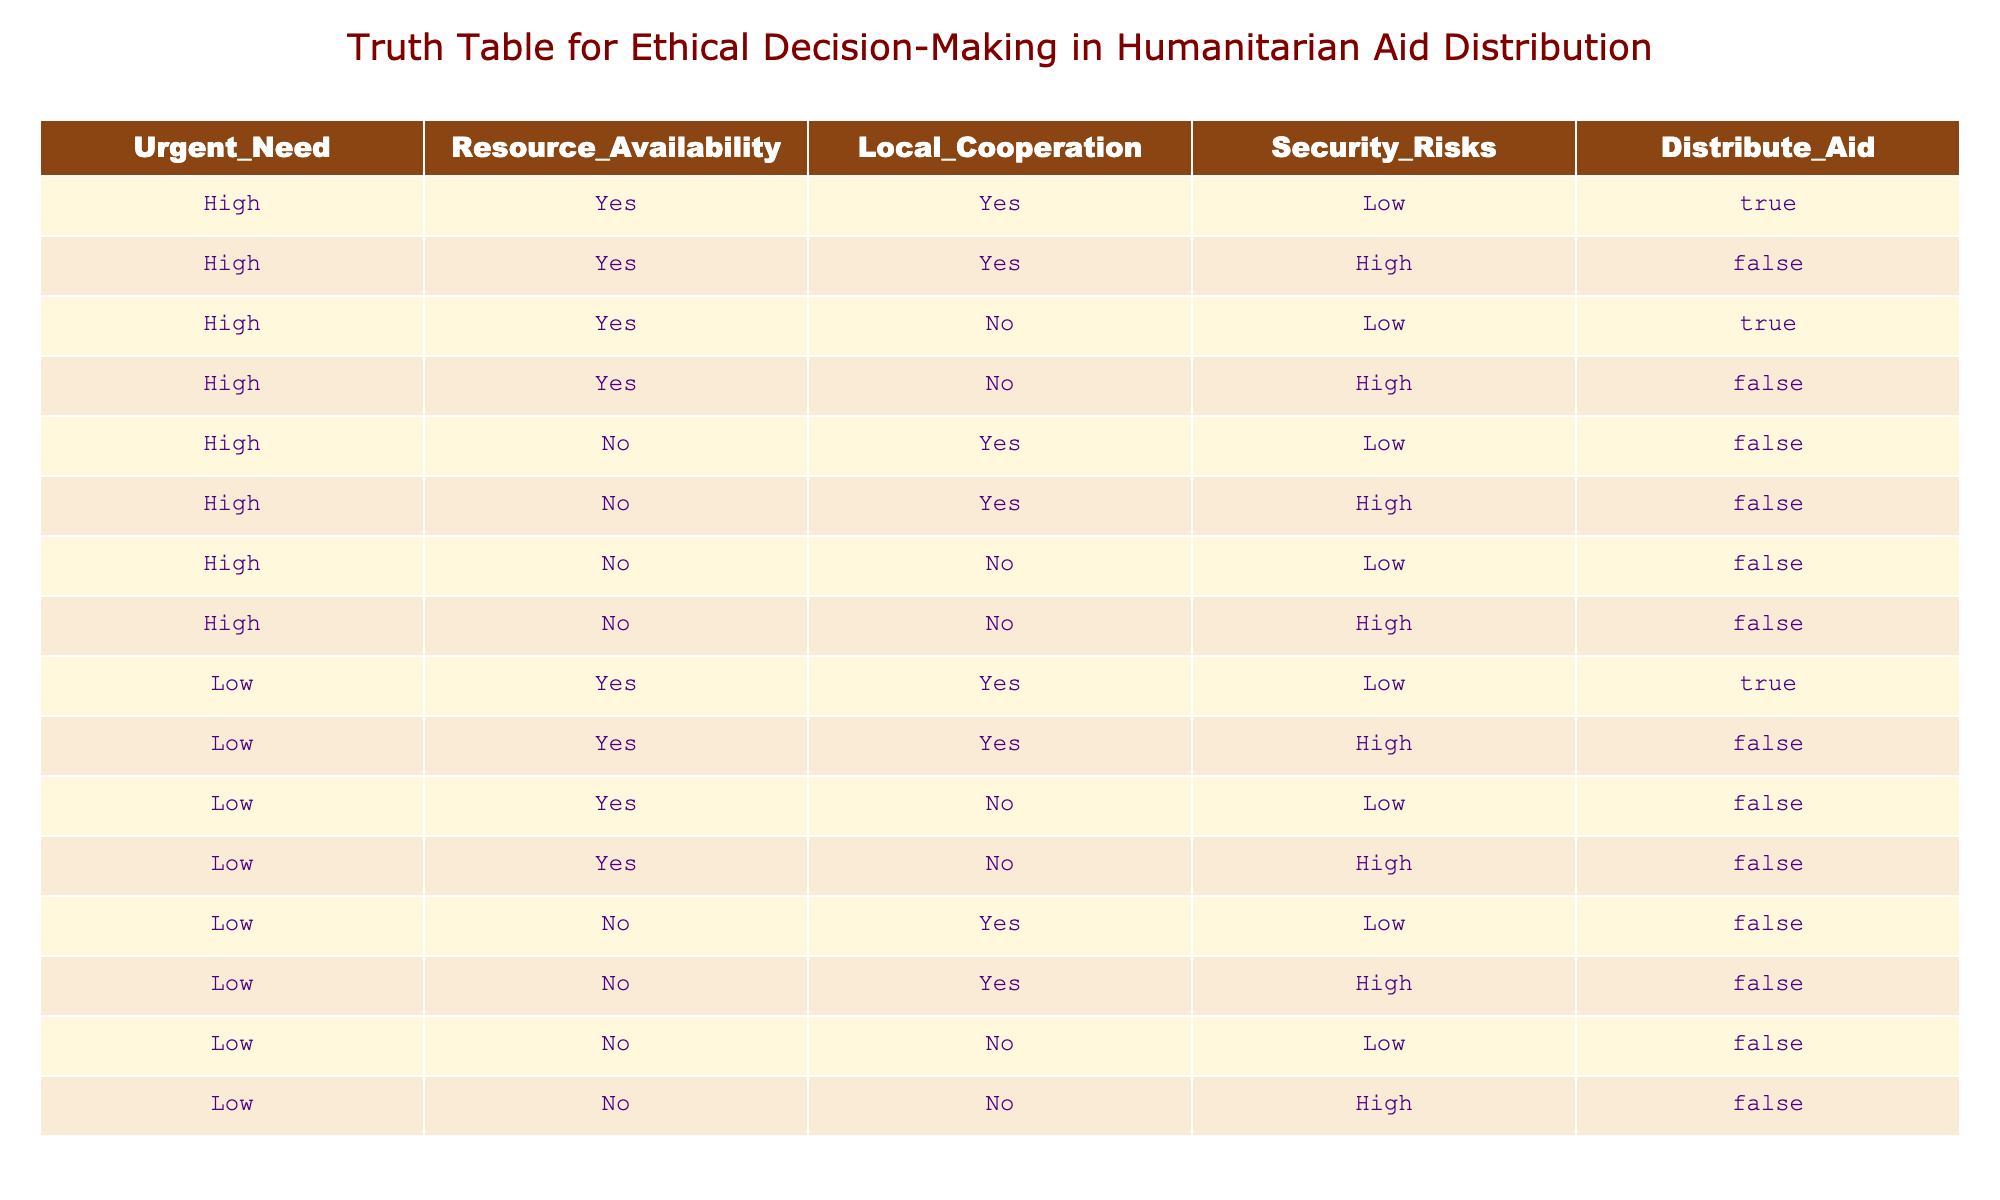What is the outcome when there is high urgent need and resource availability is yes? In looking at the table, we focus only on the rows where "Urgent_Need" is "High" and "Resource_Availability" is "Yes." There are four such rows. In two of these rows, "Distribute_Aid" is "True," and in two it is "False." Therefore, the outcome varies, and there are instances of both distributions.
Answer: Both true and false What happens in cases of high urgent need but no local cooperation and low security risks? We check the rows where "Urgent_Need" is "High," "Local_Cooperation" is "No," and "Security_Risks" is "Low." There is only one row that meets these criteria, and the value for "Distribute_Aid" is "True." Thus, in this specific case, the aid is distributed.
Answer: True How many scenarios involve high urgent need, low security risk, and local cooperation? We need to find the relevant rows where "Urgent_Need" is "High," "Security_Risks" is "Low," and "Local_Cooperation" is "Yes." There are two such rows in the table, both of which indicate "True" for "Distribute_Aid." Therefore, the total number of scenarios is two.
Answer: 2 Is there a case where low urgent need and high resource availability lead to aid distribution? To answer this, we look at the rows where "Urgent_Need" is "Low" and "Resource_Availability" is "Yes." There is one row that meets these criteria, which shows that "Distribute_Aid" is "True." So yes, there is such a case.
Answer: Yes What is the total count of instances where aid is not distributed? We tally all the rows that show "Distribute_Aid" is "False." Counting them in the table reveals there are ten instances of aid not being distributed. Hence, the total count is ten.
Answer: 10 When local cooperation is high, what percentage of instances with high urgent need secure aid distribution? To calculate this, we first look at the number of rows with both "Urgent_Need" as "High" and "Local_Cooperation" as "Yes," which is four. Out of these, there are two rows where "Distribute_Aid" is "True." Therefore, the percentage is (2/4) * 100 = 50 percent.
Answer: 50 percent Are there any cases with low urgent need and high security risks that result in aid distribution? In examining the table for rows with "Urgent_Need" as "Low" and "Security_Risks" as "High," we find two such rows. Both of these indicate "False" for "Distribute_Aid." Therefore, there are no cases where aid is distributed under these conditions.
Answer: No How many total rows indicate a high risk to security in the context of aid distribution? We need to check for rows where "Security_Risks" is "High." There are six rows that exhibit high security risks, and out of these, three indicate aid distribution as "False." Therefore, the total count of high-security risk scenarios is six.
Answer: 6 